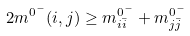<formula> <loc_0><loc_0><loc_500><loc_500>2 m ^ { 0 ^ { - } } ( i , j ) \geq m ^ { 0 ^ { - } } _ { i \bar { i } } + m ^ { 0 ^ { - } } _ { j \bar { j } }</formula> 